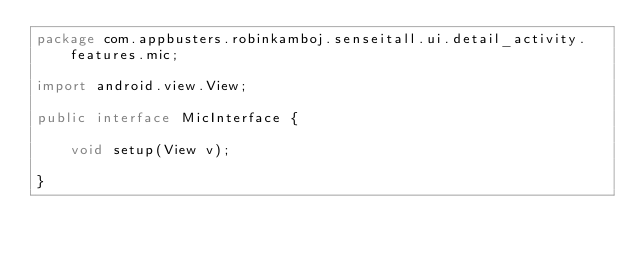<code> <loc_0><loc_0><loc_500><loc_500><_Java_>package com.appbusters.robinkamboj.senseitall.ui.detail_activity.features.mic;

import android.view.View;

public interface MicInterface {

    void setup(View v);

}
</code> 